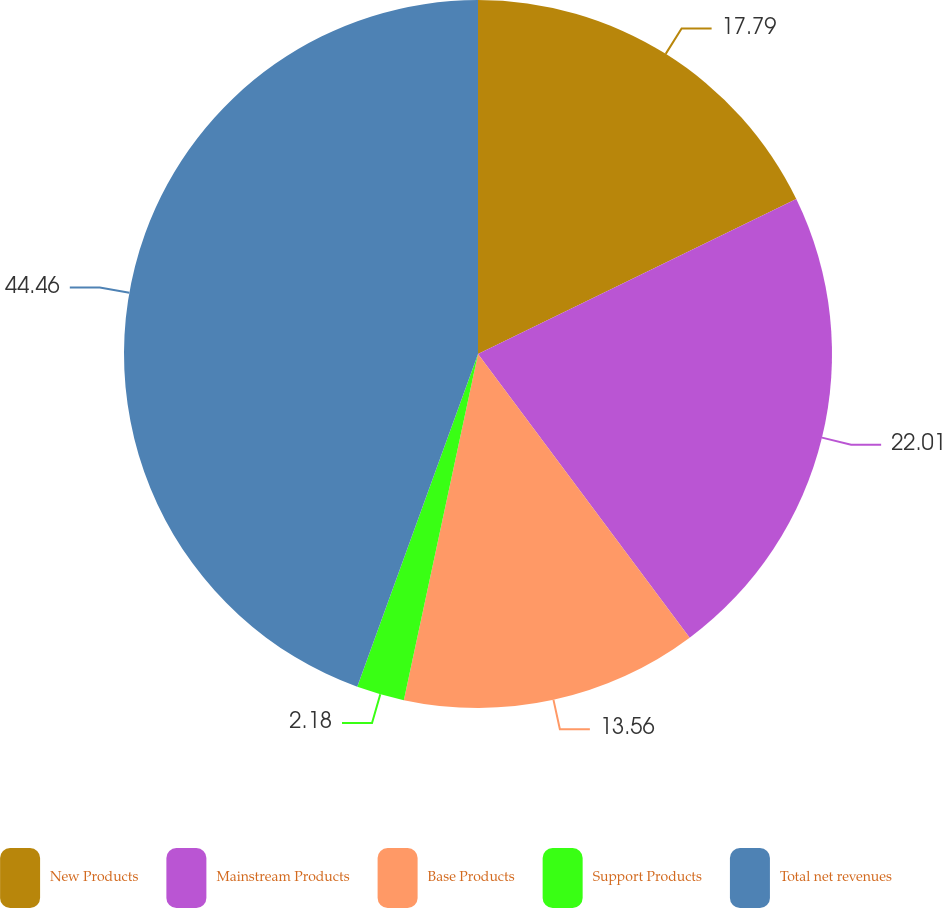Convert chart to OTSL. <chart><loc_0><loc_0><loc_500><loc_500><pie_chart><fcel>New Products<fcel>Mainstream Products<fcel>Base Products<fcel>Support Products<fcel>Total net revenues<nl><fcel>17.79%<fcel>22.01%<fcel>13.56%<fcel>2.18%<fcel>44.46%<nl></chart> 